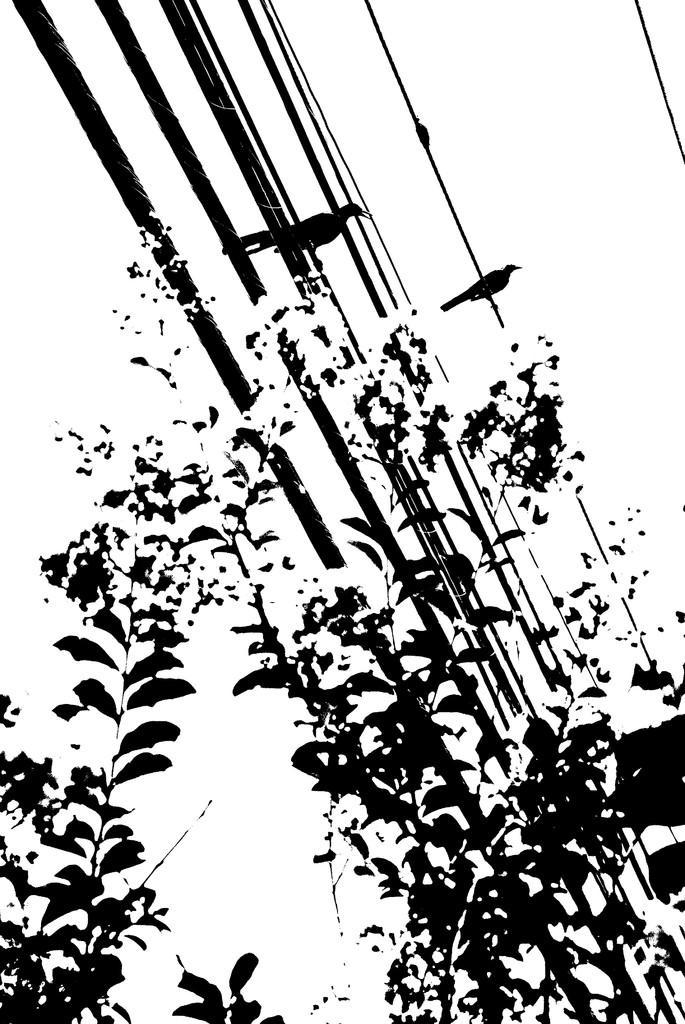Please provide a concise description of this image. This is an animation picture we see couple of birds and a tree. 